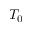<formula> <loc_0><loc_0><loc_500><loc_500>T _ { 0 }</formula> 